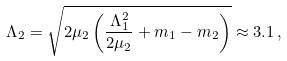Convert formula to latex. <formula><loc_0><loc_0><loc_500><loc_500>\Lambda _ { 2 } = \sqrt { 2 \mu _ { 2 } \left ( \frac { \Lambda _ { 1 } ^ { 2 } } { 2 \mu _ { 2 } } + m _ { 1 } - m _ { 2 } \right ) } \approx 3 . 1 \, ,</formula> 